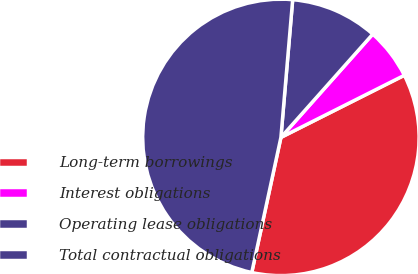<chart> <loc_0><loc_0><loc_500><loc_500><pie_chart><fcel>Long-term borrowings<fcel>Interest obligations<fcel>Operating lease obligations<fcel>Total contractual obligations<nl><fcel>35.8%<fcel>6.01%<fcel>10.21%<fcel>47.97%<nl></chart> 